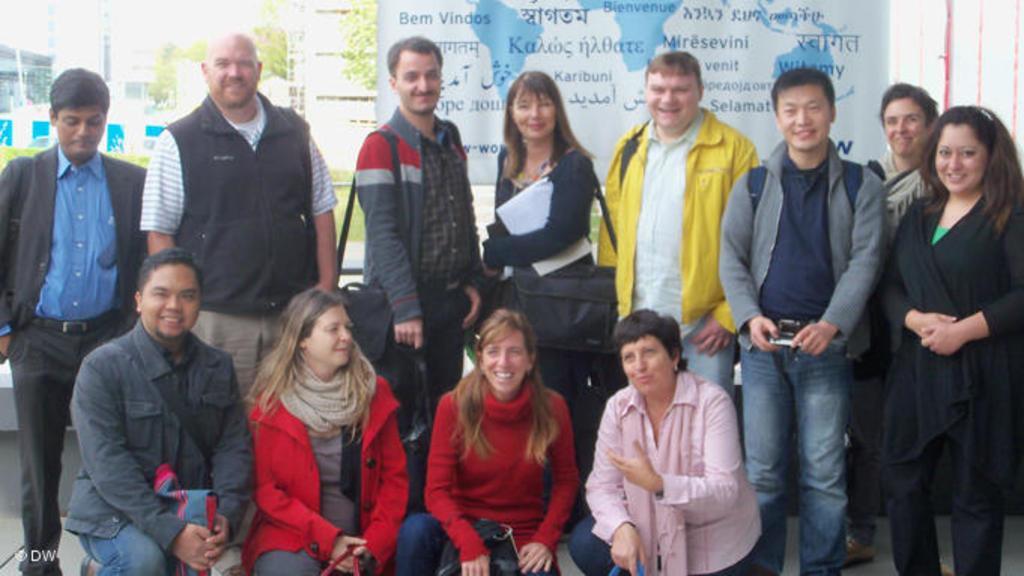Please provide a concise description of this image. In the foreground of this image, there are people posing to a camera and two are wearing bags. In the background, there is a banner, trees and buildings. 